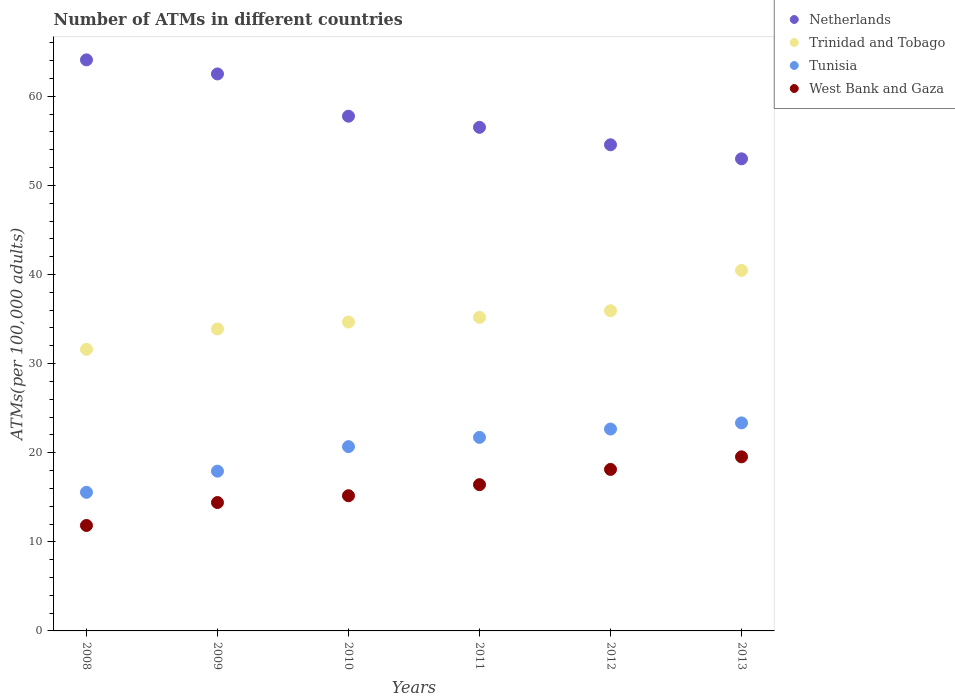How many different coloured dotlines are there?
Your answer should be very brief. 4. Is the number of dotlines equal to the number of legend labels?
Offer a very short reply. Yes. What is the number of ATMs in Tunisia in 2012?
Your response must be concise. 22.66. Across all years, what is the maximum number of ATMs in West Bank and Gaza?
Provide a succinct answer. 19.54. Across all years, what is the minimum number of ATMs in Trinidad and Tobago?
Provide a succinct answer. 31.6. What is the total number of ATMs in West Bank and Gaza in the graph?
Your response must be concise. 95.5. What is the difference between the number of ATMs in Trinidad and Tobago in 2008 and that in 2013?
Give a very brief answer. -8.86. What is the difference between the number of ATMs in West Bank and Gaza in 2010 and the number of ATMs in Netherlands in 2012?
Make the answer very short. -39.39. What is the average number of ATMs in West Bank and Gaza per year?
Your answer should be compact. 15.92. In the year 2008, what is the difference between the number of ATMs in Tunisia and number of ATMs in Netherlands?
Your answer should be compact. -48.54. What is the ratio of the number of ATMs in Netherlands in 2008 to that in 2011?
Your response must be concise. 1.13. Is the number of ATMs in Trinidad and Tobago in 2012 less than that in 2013?
Provide a short and direct response. Yes. What is the difference between the highest and the second highest number of ATMs in Tunisia?
Your answer should be very brief. 0.69. What is the difference between the highest and the lowest number of ATMs in West Bank and Gaza?
Ensure brevity in your answer.  7.7. In how many years, is the number of ATMs in Tunisia greater than the average number of ATMs in Tunisia taken over all years?
Keep it short and to the point. 4. Is it the case that in every year, the sum of the number of ATMs in Netherlands and number of ATMs in West Bank and Gaza  is greater than the sum of number of ATMs in Trinidad and Tobago and number of ATMs in Tunisia?
Provide a short and direct response. No. Is it the case that in every year, the sum of the number of ATMs in Tunisia and number of ATMs in Trinidad and Tobago  is greater than the number of ATMs in West Bank and Gaza?
Provide a short and direct response. Yes. How many dotlines are there?
Provide a short and direct response. 4. How many years are there in the graph?
Provide a short and direct response. 6. What is the difference between two consecutive major ticks on the Y-axis?
Keep it short and to the point. 10. Where does the legend appear in the graph?
Your answer should be very brief. Top right. How many legend labels are there?
Provide a succinct answer. 4. What is the title of the graph?
Give a very brief answer. Number of ATMs in different countries. Does "Guam" appear as one of the legend labels in the graph?
Your answer should be compact. No. What is the label or title of the Y-axis?
Ensure brevity in your answer.  ATMs(per 100,0 adults). What is the ATMs(per 100,000 adults) of Netherlands in 2008?
Provide a succinct answer. 64.1. What is the ATMs(per 100,000 adults) in Trinidad and Tobago in 2008?
Your answer should be compact. 31.6. What is the ATMs(per 100,000 adults) of Tunisia in 2008?
Give a very brief answer. 15.56. What is the ATMs(per 100,000 adults) of West Bank and Gaza in 2008?
Your answer should be very brief. 11.84. What is the ATMs(per 100,000 adults) in Netherlands in 2009?
Your answer should be very brief. 62.52. What is the ATMs(per 100,000 adults) in Trinidad and Tobago in 2009?
Your response must be concise. 33.89. What is the ATMs(per 100,000 adults) of Tunisia in 2009?
Keep it short and to the point. 17.93. What is the ATMs(per 100,000 adults) of West Bank and Gaza in 2009?
Offer a very short reply. 14.41. What is the ATMs(per 100,000 adults) of Netherlands in 2010?
Provide a short and direct response. 57.77. What is the ATMs(per 100,000 adults) of Trinidad and Tobago in 2010?
Your answer should be compact. 34.67. What is the ATMs(per 100,000 adults) of Tunisia in 2010?
Your answer should be very brief. 20.68. What is the ATMs(per 100,000 adults) of West Bank and Gaza in 2010?
Make the answer very short. 15.17. What is the ATMs(per 100,000 adults) of Netherlands in 2011?
Your response must be concise. 56.52. What is the ATMs(per 100,000 adults) of Trinidad and Tobago in 2011?
Offer a very short reply. 35.19. What is the ATMs(per 100,000 adults) in Tunisia in 2011?
Your answer should be very brief. 21.72. What is the ATMs(per 100,000 adults) of West Bank and Gaza in 2011?
Make the answer very short. 16.42. What is the ATMs(per 100,000 adults) in Netherlands in 2012?
Your answer should be very brief. 54.56. What is the ATMs(per 100,000 adults) of Trinidad and Tobago in 2012?
Keep it short and to the point. 35.94. What is the ATMs(per 100,000 adults) of Tunisia in 2012?
Your answer should be compact. 22.66. What is the ATMs(per 100,000 adults) in West Bank and Gaza in 2012?
Your response must be concise. 18.13. What is the ATMs(per 100,000 adults) of Netherlands in 2013?
Offer a very short reply. 52.99. What is the ATMs(per 100,000 adults) in Trinidad and Tobago in 2013?
Provide a succinct answer. 40.47. What is the ATMs(per 100,000 adults) in Tunisia in 2013?
Offer a terse response. 23.35. What is the ATMs(per 100,000 adults) in West Bank and Gaza in 2013?
Your answer should be compact. 19.54. Across all years, what is the maximum ATMs(per 100,000 adults) of Netherlands?
Your response must be concise. 64.1. Across all years, what is the maximum ATMs(per 100,000 adults) in Trinidad and Tobago?
Provide a succinct answer. 40.47. Across all years, what is the maximum ATMs(per 100,000 adults) in Tunisia?
Your response must be concise. 23.35. Across all years, what is the maximum ATMs(per 100,000 adults) in West Bank and Gaza?
Give a very brief answer. 19.54. Across all years, what is the minimum ATMs(per 100,000 adults) in Netherlands?
Offer a very short reply. 52.99. Across all years, what is the minimum ATMs(per 100,000 adults) in Trinidad and Tobago?
Your answer should be very brief. 31.6. Across all years, what is the minimum ATMs(per 100,000 adults) of Tunisia?
Provide a short and direct response. 15.56. Across all years, what is the minimum ATMs(per 100,000 adults) of West Bank and Gaza?
Ensure brevity in your answer.  11.84. What is the total ATMs(per 100,000 adults) of Netherlands in the graph?
Make the answer very short. 348.46. What is the total ATMs(per 100,000 adults) in Trinidad and Tobago in the graph?
Ensure brevity in your answer.  211.76. What is the total ATMs(per 100,000 adults) of Tunisia in the graph?
Offer a terse response. 121.9. What is the total ATMs(per 100,000 adults) of West Bank and Gaza in the graph?
Give a very brief answer. 95.5. What is the difference between the ATMs(per 100,000 adults) in Netherlands in 2008 and that in 2009?
Make the answer very short. 1.58. What is the difference between the ATMs(per 100,000 adults) in Trinidad and Tobago in 2008 and that in 2009?
Offer a terse response. -2.29. What is the difference between the ATMs(per 100,000 adults) in Tunisia in 2008 and that in 2009?
Give a very brief answer. -2.37. What is the difference between the ATMs(per 100,000 adults) in West Bank and Gaza in 2008 and that in 2009?
Keep it short and to the point. -2.57. What is the difference between the ATMs(per 100,000 adults) in Netherlands in 2008 and that in 2010?
Keep it short and to the point. 6.32. What is the difference between the ATMs(per 100,000 adults) of Trinidad and Tobago in 2008 and that in 2010?
Offer a terse response. -3.06. What is the difference between the ATMs(per 100,000 adults) of Tunisia in 2008 and that in 2010?
Your response must be concise. -5.13. What is the difference between the ATMs(per 100,000 adults) of West Bank and Gaza in 2008 and that in 2010?
Keep it short and to the point. -3.34. What is the difference between the ATMs(per 100,000 adults) in Netherlands in 2008 and that in 2011?
Offer a very short reply. 7.57. What is the difference between the ATMs(per 100,000 adults) in Trinidad and Tobago in 2008 and that in 2011?
Make the answer very short. -3.59. What is the difference between the ATMs(per 100,000 adults) of Tunisia in 2008 and that in 2011?
Provide a short and direct response. -6.17. What is the difference between the ATMs(per 100,000 adults) in West Bank and Gaza in 2008 and that in 2011?
Provide a succinct answer. -4.58. What is the difference between the ATMs(per 100,000 adults) of Netherlands in 2008 and that in 2012?
Your answer should be compact. 9.53. What is the difference between the ATMs(per 100,000 adults) of Trinidad and Tobago in 2008 and that in 2012?
Make the answer very short. -4.33. What is the difference between the ATMs(per 100,000 adults) in Tunisia in 2008 and that in 2012?
Your answer should be very brief. -7.1. What is the difference between the ATMs(per 100,000 adults) of West Bank and Gaza in 2008 and that in 2012?
Your answer should be very brief. -6.29. What is the difference between the ATMs(per 100,000 adults) of Netherlands in 2008 and that in 2013?
Ensure brevity in your answer.  11.11. What is the difference between the ATMs(per 100,000 adults) in Trinidad and Tobago in 2008 and that in 2013?
Your answer should be very brief. -8.86. What is the difference between the ATMs(per 100,000 adults) in Tunisia in 2008 and that in 2013?
Give a very brief answer. -7.79. What is the difference between the ATMs(per 100,000 adults) of West Bank and Gaza in 2008 and that in 2013?
Ensure brevity in your answer.  -7.7. What is the difference between the ATMs(per 100,000 adults) of Netherlands in 2009 and that in 2010?
Provide a succinct answer. 4.74. What is the difference between the ATMs(per 100,000 adults) of Trinidad and Tobago in 2009 and that in 2010?
Offer a very short reply. -0.78. What is the difference between the ATMs(per 100,000 adults) in Tunisia in 2009 and that in 2010?
Your response must be concise. -2.75. What is the difference between the ATMs(per 100,000 adults) in West Bank and Gaza in 2009 and that in 2010?
Your response must be concise. -0.76. What is the difference between the ATMs(per 100,000 adults) of Netherlands in 2009 and that in 2011?
Provide a short and direct response. 5.99. What is the difference between the ATMs(per 100,000 adults) in Trinidad and Tobago in 2009 and that in 2011?
Make the answer very short. -1.3. What is the difference between the ATMs(per 100,000 adults) of Tunisia in 2009 and that in 2011?
Make the answer very short. -3.79. What is the difference between the ATMs(per 100,000 adults) of West Bank and Gaza in 2009 and that in 2011?
Provide a succinct answer. -2.01. What is the difference between the ATMs(per 100,000 adults) in Netherlands in 2009 and that in 2012?
Your answer should be compact. 7.95. What is the difference between the ATMs(per 100,000 adults) of Trinidad and Tobago in 2009 and that in 2012?
Ensure brevity in your answer.  -2.05. What is the difference between the ATMs(per 100,000 adults) of Tunisia in 2009 and that in 2012?
Provide a succinct answer. -4.73. What is the difference between the ATMs(per 100,000 adults) in West Bank and Gaza in 2009 and that in 2012?
Offer a very short reply. -3.72. What is the difference between the ATMs(per 100,000 adults) in Netherlands in 2009 and that in 2013?
Give a very brief answer. 9.53. What is the difference between the ATMs(per 100,000 adults) in Trinidad and Tobago in 2009 and that in 2013?
Your answer should be compact. -6.58. What is the difference between the ATMs(per 100,000 adults) of Tunisia in 2009 and that in 2013?
Your answer should be very brief. -5.42. What is the difference between the ATMs(per 100,000 adults) in West Bank and Gaza in 2009 and that in 2013?
Provide a succinct answer. -5.13. What is the difference between the ATMs(per 100,000 adults) in Netherlands in 2010 and that in 2011?
Provide a succinct answer. 1.25. What is the difference between the ATMs(per 100,000 adults) of Trinidad and Tobago in 2010 and that in 2011?
Give a very brief answer. -0.52. What is the difference between the ATMs(per 100,000 adults) in Tunisia in 2010 and that in 2011?
Ensure brevity in your answer.  -1.04. What is the difference between the ATMs(per 100,000 adults) of West Bank and Gaza in 2010 and that in 2011?
Ensure brevity in your answer.  -1.24. What is the difference between the ATMs(per 100,000 adults) of Netherlands in 2010 and that in 2012?
Your answer should be compact. 3.21. What is the difference between the ATMs(per 100,000 adults) in Trinidad and Tobago in 2010 and that in 2012?
Make the answer very short. -1.27. What is the difference between the ATMs(per 100,000 adults) in Tunisia in 2010 and that in 2012?
Offer a terse response. -1.98. What is the difference between the ATMs(per 100,000 adults) in West Bank and Gaza in 2010 and that in 2012?
Ensure brevity in your answer.  -2.95. What is the difference between the ATMs(per 100,000 adults) in Netherlands in 2010 and that in 2013?
Provide a succinct answer. 4.78. What is the difference between the ATMs(per 100,000 adults) in Trinidad and Tobago in 2010 and that in 2013?
Offer a very short reply. -5.8. What is the difference between the ATMs(per 100,000 adults) of Tunisia in 2010 and that in 2013?
Your answer should be very brief. -2.67. What is the difference between the ATMs(per 100,000 adults) of West Bank and Gaza in 2010 and that in 2013?
Your response must be concise. -4.37. What is the difference between the ATMs(per 100,000 adults) in Netherlands in 2011 and that in 2012?
Keep it short and to the point. 1.96. What is the difference between the ATMs(per 100,000 adults) of Trinidad and Tobago in 2011 and that in 2012?
Give a very brief answer. -0.75. What is the difference between the ATMs(per 100,000 adults) in Tunisia in 2011 and that in 2012?
Your response must be concise. -0.94. What is the difference between the ATMs(per 100,000 adults) in West Bank and Gaza in 2011 and that in 2012?
Provide a succinct answer. -1.71. What is the difference between the ATMs(per 100,000 adults) of Netherlands in 2011 and that in 2013?
Ensure brevity in your answer.  3.53. What is the difference between the ATMs(per 100,000 adults) in Trinidad and Tobago in 2011 and that in 2013?
Your answer should be very brief. -5.28. What is the difference between the ATMs(per 100,000 adults) of Tunisia in 2011 and that in 2013?
Give a very brief answer. -1.63. What is the difference between the ATMs(per 100,000 adults) in West Bank and Gaza in 2011 and that in 2013?
Your response must be concise. -3.12. What is the difference between the ATMs(per 100,000 adults) in Netherlands in 2012 and that in 2013?
Your response must be concise. 1.58. What is the difference between the ATMs(per 100,000 adults) in Trinidad and Tobago in 2012 and that in 2013?
Your answer should be compact. -4.53. What is the difference between the ATMs(per 100,000 adults) in Tunisia in 2012 and that in 2013?
Your answer should be very brief. -0.69. What is the difference between the ATMs(per 100,000 adults) of West Bank and Gaza in 2012 and that in 2013?
Offer a very short reply. -1.41. What is the difference between the ATMs(per 100,000 adults) in Netherlands in 2008 and the ATMs(per 100,000 adults) in Trinidad and Tobago in 2009?
Ensure brevity in your answer.  30.21. What is the difference between the ATMs(per 100,000 adults) in Netherlands in 2008 and the ATMs(per 100,000 adults) in Tunisia in 2009?
Offer a terse response. 46.17. What is the difference between the ATMs(per 100,000 adults) of Netherlands in 2008 and the ATMs(per 100,000 adults) of West Bank and Gaza in 2009?
Your answer should be very brief. 49.69. What is the difference between the ATMs(per 100,000 adults) in Trinidad and Tobago in 2008 and the ATMs(per 100,000 adults) in Tunisia in 2009?
Give a very brief answer. 13.67. What is the difference between the ATMs(per 100,000 adults) in Trinidad and Tobago in 2008 and the ATMs(per 100,000 adults) in West Bank and Gaza in 2009?
Provide a short and direct response. 17.19. What is the difference between the ATMs(per 100,000 adults) in Tunisia in 2008 and the ATMs(per 100,000 adults) in West Bank and Gaza in 2009?
Give a very brief answer. 1.15. What is the difference between the ATMs(per 100,000 adults) of Netherlands in 2008 and the ATMs(per 100,000 adults) of Trinidad and Tobago in 2010?
Offer a terse response. 29.43. What is the difference between the ATMs(per 100,000 adults) in Netherlands in 2008 and the ATMs(per 100,000 adults) in Tunisia in 2010?
Give a very brief answer. 43.41. What is the difference between the ATMs(per 100,000 adults) in Netherlands in 2008 and the ATMs(per 100,000 adults) in West Bank and Gaza in 2010?
Your answer should be compact. 48.92. What is the difference between the ATMs(per 100,000 adults) of Trinidad and Tobago in 2008 and the ATMs(per 100,000 adults) of Tunisia in 2010?
Your answer should be very brief. 10.92. What is the difference between the ATMs(per 100,000 adults) in Trinidad and Tobago in 2008 and the ATMs(per 100,000 adults) in West Bank and Gaza in 2010?
Offer a terse response. 16.43. What is the difference between the ATMs(per 100,000 adults) of Tunisia in 2008 and the ATMs(per 100,000 adults) of West Bank and Gaza in 2010?
Provide a short and direct response. 0.38. What is the difference between the ATMs(per 100,000 adults) in Netherlands in 2008 and the ATMs(per 100,000 adults) in Trinidad and Tobago in 2011?
Provide a succinct answer. 28.9. What is the difference between the ATMs(per 100,000 adults) in Netherlands in 2008 and the ATMs(per 100,000 adults) in Tunisia in 2011?
Offer a very short reply. 42.37. What is the difference between the ATMs(per 100,000 adults) in Netherlands in 2008 and the ATMs(per 100,000 adults) in West Bank and Gaza in 2011?
Make the answer very short. 47.68. What is the difference between the ATMs(per 100,000 adults) in Trinidad and Tobago in 2008 and the ATMs(per 100,000 adults) in Tunisia in 2011?
Ensure brevity in your answer.  9.88. What is the difference between the ATMs(per 100,000 adults) of Trinidad and Tobago in 2008 and the ATMs(per 100,000 adults) of West Bank and Gaza in 2011?
Your answer should be very brief. 15.19. What is the difference between the ATMs(per 100,000 adults) of Tunisia in 2008 and the ATMs(per 100,000 adults) of West Bank and Gaza in 2011?
Your answer should be very brief. -0.86. What is the difference between the ATMs(per 100,000 adults) in Netherlands in 2008 and the ATMs(per 100,000 adults) in Trinidad and Tobago in 2012?
Make the answer very short. 28.16. What is the difference between the ATMs(per 100,000 adults) of Netherlands in 2008 and the ATMs(per 100,000 adults) of Tunisia in 2012?
Keep it short and to the point. 41.44. What is the difference between the ATMs(per 100,000 adults) of Netherlands in 2008 and the ATMs(per 100,000 adults) of West Bank and Gaza in 2012?
Give a very brief answer. 45.97. What is the difference between the ATMs(per 100,000 adults) in Trinidad and Tobago in 2008 and the ATMs(per 100,000 adults) in Tunisia in 2012?
Offer a very short reply. 8.94. What is the difference between the ATMs(per 100,000 adults) of Trinidad and Tobago in 2008 and the ATMs(per 100,000 adults) of West Bank and Gaza in 2012?
Your response must be concise. 13.48. What is the difference between the ATMs(per 100,000 adults) in Tunisia in 2008 and the ATMs(per 100,000 adults) in West Bank and Gaza in 2012?
Your answer should be very brief. -2.57. What is the difference between the ATMs(per 100,000 adults) of Netherlands in 2008 and the ATMs(per 100,000 adults) of Trinidad and Tobago in 2013?
Your response must be concise. 23.63. What is the difference between the ATMs(per 100,000 adults) of Netherlands in 2008 and the ATMs(per 100,000 adults) of Tunisia in 2013?
Your answer should be compact. 40.75. What is the difference between the ATMs(per 100,000 adults) in Netherlands in 2008 and the ATMs(per 100,000 adults) in West Bank and Gaza in 2013?
Give a very brief answer. 44.56. What is the difference between the ATMs(per 100,000 adults) in Trinidad and Tobago in 2008 and the ATMs(per 100,000 adults) in Tunisia in 2013?
Your response must be concise. 8.25. What is the difference between the ATMs(per 100,000 adults) of Trinidad and Tobago in 2008 and the ATMs(per 100,000 adults) of West Bank and Gaza in 2013?
Ensure brevity in your answer.  12.06. What is the difference between the ATMs(per 100,000 adults) in Tunisia in 2008 and the ATMs(per 100,000 adults) in West Bank and Gaza in 2013?
Ensure brevity in your answer.  -3.98. What is the difference between the ATMs(per 100,000 adults) of Netherlands in 2009 and the ATMs(per 100,000 adults) of Trinidad and Tobago in 2010?
Provide a short and direct response. 27.85. What is the difference between the ATMs(per 100,000 adults) of Netherlands in 2009 and the ATMs(per 100,000 adults) of Tunisia in 2010?
Offer a terse response. 41.83. What is the difference between the ATMs(per 100,000 adults) of Netherlands in 2009 and the ATMs(per 100,000 adults) of West Bank and Gaza in 2010?
Give a very brief answer. 47.34. What is the difference between the ATMs(per 100,000 adults) in Trinidad and Tobago in 2009 and the ATMs(per 100,000 adults) in Tunisia in 2010?
Offer a terse response. 13.21. What is the difference between the ATMs(per 100,000 adults) of Trinidad and Tobago in 2009 and the ATMs(per 100,000 adults) of West Bank and Gaza in 2010?
Offer a terse response. 18.72. What is the difference between the ATMs(per 100,000 adults) of Tunisia in 2009 and the ATMs(per 100,000 adults) of West Bank and Gaza in 2010?
Your answer should be very brief. 2.76. What is the difference between the ATMs(per 100,000 adults) of Netherlands in 2009 and the ATMs(per 100,000 adults) of Trinidad and Tobago in 2011?
Provide a succinct answer. 27.33. What is the difference between the ATMs(per 100,000 adults) of Netherlands in 2009 and the ATMs(per 100,000 adults) of Tunisia in 2011?
Offer a very short reply. 40.79. What is the difference between the ATMs(per 100,000 adults) of Netherlands in 2009 and the ATMs(per 100,000 adults) of West Bank and Gaza in 2011?
Offer a terse response. 46.1. What is the difference between the ATMs(per 100,000 adults) of Trinidad and Tobago in 2009 and the ATMs(per 100,000 adults) of Tunisia in 2011?
Give a very brief answer. 12.17. What is the difference between the ATMs(per 100,000 adults) of Trinidad and Tobago in 2009 and the ATMs(per 100,000 adults) of West Bank and Gaza in 2011?
Your response must be concise. 17.47. What is the difference between the ATMs(per 100,000 adults) in Tunisia in 2009 and the ATMs(per 100,000 adults) in West Bank and Gaza in 2011?
Make the answer very short. 1.51. What is the difference between the ATMs(per 100,000 adults) in Netherlands in 2009 and the ATMs(per 100,000 adults) in Trinidad and Tobago in 2012?
Your answer should be very brief. 26.58. What is the difference between the ATMs(per 100,000 adults) in Netherlands in 2009 and the ATMs(per 100,000 adults) in Tunisia in 2012?
Keep it short and to the point. 39.86. What is the difference between the ATMs(per 100,000 adults) in Netherlands in 2009 and the ATMs(per 100,000 adults) in West Bank and Gaza in 2012?
Offer a very short reply. 44.39. What is the difference between the ATMs(per 100,000 adults) of Trinidad and Tobago in 2009 and the ATMs(per 100,000 adults) of Tunisia in 2012?
Provide a short and direct response. 11.23. What is the difference between the ATMs(per 100,000 adults) of Trinidad and Tobago in 2009 and the ATMs(per 100,000 adults) of West Bank and Gaza in 2012?
Ensure brevity in your answer.  15.76. What is the difference between the ATMs(per 100,000 adults) in Tunisia in 2009 and the ATMs(per 100,000 adults) in West Bank and Gaza in 2012?
Your answer should be very brief. -0.2. What is the difference between the ATMs(per 100,000 adults) in Netherlands in 2009 and the ATMs(per 100,000 adults) in Trinidad and Tobago in 2013?
Give a very brief answer. 22.05. What is the difference between the ATMs(per 100,000 adults) in Netherlands in 2009 and the ATMs(per 100,000 adults) in Tunisia in 2013?
Give a very brief answer. 39.17. What is the difference between the ATMs(per 100,000 adults) of Netherlands in 2009 and the ATMs(per 100,000 adults) of West Bank and Gaza in 2013?
Ensure brevity in your answer.  42.98. What is the difference between the ATMs(per 100,000 adults) in Trinidad and Tobago in 2009 and the ATMs(per 100,000 adults) in Tunisia in 2013?
Keep it short and to the point. 10.54. What is the difference between the ATMs(per 100,000 adults) in Trinidad and Tobago in 2009 and the ATMs(per 100,000 adults) in West Bank and Gaza in 2013?
Provide a short and direct response. 14.35. What is the difference between the ATMs(per 100,000 adults) in Tunisia in 2009 and the ATMs(per 100,000 adults) in West Bank and Gaza in 2013?
Keep it short and to the point. -1.61. What is the difference between the ATMs(per 100,000 adults) of Netherlands in 2010 and the ATMs(per 100,000 adults) of Trinidad and Tobago in 2011?
Offer a terse response. 22.58. What is the difference between the ATMs(per 100,000 adults) in Netherlands in 2010 and the ATMs(per 100,000 adults) in Tunisia in 2011?
Provide a short and direct response. 36.05. What is the difference between the ATMs(per 100,000 adults) in Netherlands in 2010 and the ATMs(per 100,000 adults) in West Bank and Gaza in 2011?
Give a very brief answer. 41.36. What is the difference between the ATMs(per 100,000 adults) of Trinidad and Tobago in 2010 and the ATMs(per 100,000 adults) of Tunisia in 2011?
Your answer should be very brief. 12.94. What is the difference between the ATMs(per 100,000 adults) of Trinidad and Tobago in 2010 and the ATMs(per 100,000 adults) of West Bank and Gaza in 2011?
Give a very brief answer. 18.25. What is the difference between the ATMs(per 100,000 adults) in Tunisia in 2010 and the ATMs(per 100,000 adults) in West Bank and Gaza in 2011?
Your answer should be compact. 4.27. What is the difference between the ATMs(per 100,000 adults) in Netherlands in 2010 and the ATMs(per 100,000 adults) in Trinidad and Tobago in 2012?
Keep it short and to the point. 21.84. What is the difference between the ATMs(per 100,000 adults) in Netherlands in 2010 and the ATMs(per 100,000 adults) in Tunisia in 2012?
Your answer should be very brief. 35.11. What is the difference between the ATMs(per 100,000 adults) in Netherlands in 2010 and the ATMs(per 100,000 adults) in West Bank and Gaza in 2012?
Ensure brevity in your answer.  39.64. What is the difference between the ATMs(per 100,000 adults) of Trinidad and Tobago in 2010 and the ATMs(per 100,000 adults) of Tunisia in 2012?
Make the answer very short. 12.01. What is the difference between the ATMs(per 100,000 adults) in Trinidad and Tobago in 2010 and the ATMs(per 100,000 adults) in West Bank and Gaza in 2012?
Make the answer very short. 16.54. What is the difference between the ATMs(per 100,000 adults) in Tunisia in 2010 and the ATMs(per 100,000 adults) in West Bank and Gaza in 2012?
Keep it short and to the point. 2.56. What is the difference between the ATMs(per 100,000 adults) in Netherlands in 2010 and the ATMs(per 100,000 adults) in Trinidad and Tobago in 2013?
Your answer should be compact. 17.31. What is the difference between the ATMs(per 100,000 adults) in Netherlands in 2010 and the ATMs(per 100,000 adults) in Tunisia in 2013?
Make the answer very short. 34.42. What is the difference between the ATMs(per 100,000 adults) in Netherlands in 2010 and the ATMs(per 100,000 adults) in West Bank and Gaza in 2013?
Ensure brevity in your answer.  38.23. What is the difference between the ATMs(per 100,000 adults) in Trinidad and Tobago in 2010 and the ATMs(per 100,000 adults) in Tunisia in 2013?
Your response must be concise. 11.32. What is the difference between the ATMs(per 100,000 adults) in Trinidad and Tobago in 2010 and the ATMs(per 100,000 adults) in West Bank and Gaza in 2013?
Your answer should be compact. 15.13. What is the difference between the ATMs(per 100,000 adults) of Tunisia in 2010 and the ATMs(per 100,000 adults) of West Bank and Gaza in 2013?
Your answer should be very brief. 1.14. What is the difference between the ATMs(per 100,000 adults) of Netherlands in 2011 and the ATMs(per 100,000 adults) of Trinidad and Tobago in 2012?
Your answer should be very brief. 20.59. What is the difference between the ATMs(per 100,000 adults) of Netherlands in 2011 and the ATMs(per 100,000 adults) of Tunisia in 2012?
Provide a succinct answer. 33.86. What is the difference between the ATMs(per 100,000 adults) of Netherlands in 2011 and the ATMs(per 100,000 adults) of West Bank and Gaza in 2012?
Ensure brevity in your answer.  38.4. What is the difference between the ATMs(per 100,000 adults) in Trinidad and Tobago in 2011 and the ATMs(per 100,000 adults) in Tunisia in 2012?
Keep it short and to the point. 12.53. What is the difference between the ATMs(per 100,000 adults) in Trinidad and Tobago in 2011 and the ATMs(per 100,000 adults) in West Bank and Gaza in 2012?
Give a very brief answer. 17.06. What is the difference between the ATMs(per 100,000 adults) in Tunisia in 2011 and the ATMs(per 100,000 adults) in West Bank and Gaza in 2012?
Ensure brevity in your answer.  3.59. What is the difference between the ATMs(per 100,000 adults) in Netherlands in 2011 and the ATMs(per 100,000 adults) in Trinidad and Tobago in 2013?
Give a very brief answer. 16.06. What is the difference between the ATMs(per 100,000 adults) of Netherlands in 2011 and the ATMs(per 100,000 adults) of Tunisia in 2013?
Your response must be concise. 33.17. What is the difference between the ATMs(per 100,000 adults) in Netherlands in 2011 and the ATMs(per 100,000 adults) in West Bank and Gaza in 2013?
Your answer should be compact. 36.98. What is the difference between the ATMs(per 100,000 adults) of Trinidad and Tobago in 2011 and the ATMs(per 100,000 adults) of Tunisia in 2013?
Offer a very short reply. 11.84. What is the difference between the ATMs(per 100,000 adults) of Trinidad and Tobago in 2011 and the ATMs(per 100,000 adults) of West Bank and Gaza in 2013?
Keep it short and to the point. 15.65. What is the difference between the ATMs(per 100,000 adults) in Tunisia in 2011 and the ATMs(per 100,000 adults) in West Bank and Gaza in 2013?
Your answer should be very brief. 2.18. What is the difference between the ATMs(per 100,000 adults) in Netherlands in 2012 and the ATMs(per 100,000 adults) in Trinidad and Tobago in 2013?
Your response must be concise. 14.1. What is the difference between the ATMs(per 100,000 adults) of Netherlands in 2012 and the ATMs(per 100,000 adults) of Tunisia in 2013?
Provide a short and direct response. 31.22. What is the difference between the ATMs(per 100,000 adults) in Netherlands in 2012 and the ATMs(per 100,000 adults) in West Bank and Gaza in 2013?
Your answer should be compact. 35.02. What is the difference between the ATMs(per 100,000 adults) of Trinidad and Tobago in 2012 and the ATMs(per 100,000 adults) of Tunisia in 2013?
Offer a terse response. 12.59. What is the difference between the ATMs(per 100,000 adults) of Trinidad and Tobago in 2012 and the ATMs(per 100,000 adults) of West Bank and Gaza in 2013?
Provide a succinct answer. 16.4. What is the difference between the ATMs(per 100,000 adults) in Tunisia in 2012 and the ATMs(per 100,000 adults) in West Bank and Gaza in 2013?
Your answer should be compact. 3.12. What is the average ATMs(per 100,000 adults) of Netherlands per year?
Your answer should be very brief. 58.08. What is the average ATMs(per 100,000 adults) of Trinidad and Tobago per year?
Give a very brief answer. 35.29. What is the average ATMs(per 100,000 adults) in Tunisia per year?
Offer a very short reply. 20.32. What is the average ATMs(per 100,000 adults) in West Bank and Gaza per year?
Give a very brief answer. 15.92. In the year 2008, what is the difference between the ATMs(per 100,000 adults) in Netherlands and ATMs(per 100,000 adults) in Trinidad and Tobago?
Provide a succinct answer. 32.49. In the year 2008, what is the difference between the ATMs(per 100,000 adults) in Netherlands and ATMs(per 100,000 adults) in Tunisia?
Provide a short and direct response. 48.54. In the year 2008, what is the difference between the ATMs(per 100,000 adults) in Netherlands and ATMs(per 100,000 adults) in West Bank and Gaza?
Your response must be concise. 52.26. In the year 2008, what is the difference between the ATMs(per 100,000 adults) in Trinidad and Tobago and ATMs(per 100,000 adults) in Tunisia?
Your answer should be very brief. 16.05. In the year 2008, what is the difference between the ATMs(per 100,000 adults) of Trinidad and Tobago and ATMs(per 100,000 adults) of West Bank and Gaza?
Your answer should be very brief. 19.77. In the year 2008, what is the difference between the ATMs(per 100,000 adults) in Tunisia and ATMs(per 100,000 adults) in West Bank and Gaza?
Provide a succinct answer. 3.72. In the year 2009, what is the difference between the ATMs(per 100,000 adults) of Netherlands and ATMs(per 100,000 adults) of Trinidad and Tobago?
Give a very brief answer. 28.63. In the year 2009, what is the difference between the ATMs(per 100,000 adults) in Netherlands and ATMs(per 100,000 adults) in Tunisia?
Keep it short and to the point. 44.59. In the year 2009, what is the difference between the ATMs(per 100,000 adults) of Netherlands and ATMs(per 100,000 adults) of West Bank and Gaza?
Keep it short and to the point. 48.11. In the year 2009, what is the difference between the ATMs(per 100,000 adults) of Trinidad and Tobago and ATMs(per 100,000 adults) of Tunisia?
Give a very brief answer. 15.96. In the year 2009, what is the difference between the ATMs(per 100,000 adults) in Trinidad and Tobago and ATMs(per 100,000 adults) in West Bank and Gaza?
Keep it short and to the point. 19.48. In the year 2009, what is the difference between the ATMs(per 100,000 adults) in Tunisia and ATMs(per 100,000 adults) in West Bank and Gaza?
Provide a short and direct response. 3.52. In the year 2010, what is the difference between the ATMs(per 100,000 adults) of Netherlands and ATMs(per 100,000 adults) of Trinidad and Tobago?
Your response must be concise. 23.1. In the year 2010, what is the difference between the ATMs(per 100,000 adults) of Netherlands and ATMs(per 100,000 adults) of Tunisia?
Ensure brevity in your answer.  37.09. In the year 2010, what is the difference between the ATMs(per 100,000 adults) in Netherlands and ATMs(per 100,000 adults) in West Bank and Gaza?
Offer a terse response. 42.6. In the year 2010, what is the difference between the ATMs(per 100,000 adults) of Trinidad and Tobago and ATMs(per 100,000 adults) of Tunisia?
Offer a very short reply. 13.98. In the year 2010, what is the difference between the ATMs(per 100,000 adults) of Trinidad and Tobago and ATMs(per 100,000 adults) of West Bank and Gaza?
Keep it short and to the point. 19.49. In the year 2010, what is the difference between the ATMs(per 100,000 adults) of Tunisia and ATMs(per 100,000 adults) of West Bank and Gaza?
Make the answer very short. 5.51. In the year 2011, what is the difference between the ATMs(per 100,000 adults) of Netherlands and ATMs(per 100,000 adults) of Trinidad and Tobago?
Provide a succinct answer. 21.33. In the year 2011, what is the difference between the ATMs(per 100,000 adults) in Netherlands and ATMs(per 100,000 adults) in Tunisia?
Your response must be concise. 34.8. In the year 2011, what is the difference between the ATMs(per 100,000 adults) of Netherlands and ATMs(per 100,000 adults) of West Bank and Gaza?
Your response must be concise. 40.11. In the year 2011, what is the difference between the ATMs(per 100,000 adults) of Trinidad and Tobago and ATMs(per 100,000 adults) of Tunisia?
Keep it short and to the point. 13.47. In the year 2011, what is the difference between the ATMs(per 100,000 adults) in Trinidad and Tobago and ATMs(per 100,000 adults) in West Bank and Gaza?
Make the answer very short. 18.78. In the year 2011, what is the difference between the ATMs(per 100,000 adults) in Tunisia and ATMs(per 100,000 adults) in West Bank and Gaza?
Give a very brief answer. 5.31. In the year 2012, what is the difference between the ATMs(per 100,000 adults) of Netherlands and ATMs(per 100,000 adults) of Trinidad and Tobago?
Make the answer very short. 18.63. In the year 2012, what is the difference between the ATMs(per 100,000 adults) in Netherlands and ATMs(per 100,000 adults) in Tunisia?
Make the answer very short. 31.9. In the year 2012, what is the difference between the ATMs(per 100,000 adults) in Netherlands and ATMs(per 100,000 adults) in West Bank and Gaza?
Provide a short and direct response. 36.44. In the year 2012, what is the difference between the ATMs(per 100,000 adults) of Trinidad and Tobago and ATMs(per 100,000 adults) of Tunisia?
Your response must be concise. 13.28. In the year 2012, what is the difference between the ATMs(per 100,000 adults) in Trinidad and Tobago and ATMs(per 100,000 adults) in West Bank and Gaza?
Ensure brevity in your answer.  17.81. In the year 2012, what is the difference between the ATMs(per 100,000 adults) of Tunisia and ATMs(per 100,000 adults) of West Bank and Gaza?
Your response must be concise. 4.53. In the year 2013, what is the difference between the ATMs(per 100,000 adults) in Netherlands and ATMs(per 100,000 adults) in Trinidad and Tobago?
Offer a terse response. 12.52. In the year 2013, what is the difference between the ATMs(per 100,000 adults) in Netherlands and ATMs(per 100,000 adults) in Tunisia?
Keep it short and to the point. 29.64. In the year 2013, what is the difference between the ATMs(per 100,000 adults) of Netherlands and ATMs(per 100,000 adults) of West Bank and Gaza?
Offer a very short reply. 33.45. In the year 2013, what is the difference between the ATMs(per 100,000 adults) of Trinidad and Tobago and ATMs(per 100,000 adults) of Tunisia?
Ensure brevity in your answer.  17.12. In the year 2013, what is the difference between the ATMs(per 100,000 adults) in Trinidad and Tobago and ATMs(per 100,000 adults) in West Bank and Gaza?
Provide a succinct answer. 20.93. In the year 2013, what is the difference between the ATMs(per 100,000 adults) of Tunisia and ATMs(per 100,000 adults) of West Bank and Gaza?
Ensure brevity in your answer.  3.81. What is the ratio of the ATMs(per 100,000 adults) in Netherlands in 2008 to that in 2009?
Provide a succinct answer. 1.03. What is the ratio of the ATMs(per 100,000 adults) of Trinidad and Tobago in 2008 to that in 2009?
Give a very brief answer. 0.93. What is the ratio of the ATMs(per 100,000 adults) of Tunisia in 2008 to that in 2009?
Your response must be concise. 0.87. What is the ratio of the ATMs(per 100,000 adults) of West Bank and Gaza in 2008 to that in 2009?
Make the answer very short. 0.82. What is the ratio of the ATMs(per 100,000 adults) in Netherlands in 2008 to that in 2010?
Your answer should be very brief. 1.11. What is the ratio of the ATMs(per 100,000 adults) in Trinidad and Tobago in 2008 to that in 2010?
Your response must be concise. 0.91. What is the ratio of the ATMs(per 100,000 adults) in Tunisia in 2008 to that in 2010?
Your response must be concise. 0.75. What is the ratio of the ATMs(per 100,000 adults) of West Bank and Gaza in 2008 to that in 2010?
Offer a terse response. 0.78. What is the ratio of the ATMs(per 100,000 adults) in Netherlands in 2008 to that in 2011?
Provide a short and direct response. 1.13. What is the ratio of the ATMs(per 100,000 adults) in Trinidad and Tobago in 2008 to that in 2011?
Your answer should be compact. 0.9. What is the ratio of the ATMs(per 100,000 adults) in Tunisia in 2008 to that in 2011?
Keep it short and to the point. 0.72. What is the ratio of the ATMs(per 100,000 adults) of West Bank and Gaza in 2008 to that in 2011?
Provide a succinct answer. 0.72. What is the ratio of the ATMs(per 100,000 adults) of Netherlands in 2008 to that in 2012?
Provide a succinct answer. 1.17. What is the ratio of the ATMs(per 100,000 adults) of Trinidad and Tobago in 2008 to that in 2012?
Keep it short and to the point. 0.88. What is the ratio of the ATMs(per 100,000 adults) in Tunisia in 2008 to that in 2012?
Your answer should be very brief. 0.69. What is the ratio of the ATMs(per 100,000 adults) of West Bank and Gaza in 2008 to that in 2012?
Your answer should be very brief. 0.65. What is the ratio of the ATMs(per 100,000 adults) of Netherlands in 2008 to that in 2013?
Offer a terse response. 1.21. What is the ratio of the ATMs(per 100,000 adults) in Trinidad and Tobago in 2008 to that in 2013?
Provide a succinct answer. 0.78. What is the ratio of the ATMs(per 100,000 adults) of Tunisia in 2008 to that in 2013?
Your response must be concise. 0.67. What is the ratio of the ATMs(per 100,000 adults) in West Bank and Gaza in 2008 to that in 2013?
Offer a terse response. 0.61. What is the ratio of the ATMs(per 100,000 adults) of Netherlands in 2009 to that in 2010?
Provide a succinct answer. 1.08. What is the ratio of the ATMs(per 100,000 adults) of Trinidad and Tobago in 2009 to that in 2010?
Ensure brevity in your answer.  0.98. What is the ratio of the ATMs(per 100,000 adults) of Tunisia in 2009 to that in 2010?
Provide a short and direct response. 0.87. What is the ratio of the ATMs(per 100,000 adults) of West Bank and Gaza in 2009 to that in 2010?
Ensure brevity in your answer.  0.95. What is the ratio of the ATMs(per 100,000 adults) in Netherlands in 2009 to that in 2011?
Provide a short and direct response. 1.11. What is the ratio of the ATMs(per 100,000 adults) of Tunisia in 2009 to that in 2011?
Offer a terse response. 0.83. What is the ratio of the ATMs(per 100,000 adults) in West Bank and Gaza in 2009 to that in 2011?
Ensure brevity in your answer.  0.88. What is the ratio of the ATMs(per 100,000 adults) in Netherlands in 2009 to that in 2012?
Keep it short and to the point. 1.15. What is the ratio of the ATMs(per 100,000 adults) in Trinidad and Tobago in 2009 to that in 2012?
Ensure brevity in your answer.  0.94. What is the ratio of the ATMs(per 100,000 adults) of Tunisia in 2009 to that in 2012?
Provide a succinct answer. 0.79. What is the ratio of the ATMs(per 100,000 adults) of West Bank and Gaza in 2009 to that in 2012?
Give a very brief answer. 0.79. What is the ratio of the ATMs(per 100,000 adults) of Netherlands in 2009 to that in 2013?
Your answer should be compact. 1.18. What is the ratio of the ATMs(per 100,000 adults) of Trinidad and Tobago in 2009 to that in 2013?
Your answer should be very brief. 0.84. What is the ratio of the ATMs(per 100,000 adults) of Tunisia in 2009 to that in 2013?
Offer a terse response. 0.77. What is the ratio of the ATMs(per 100,000 adults) of West Bank and Gaza in 2009 to that in 2013?
Your answer should be compact. 0.74. What is the ratio of the ATMs(per 100,000 adults) of Netherlands in 2010 to that in 2011?
Provide a succinct answer. 1.02. What is the ratio of the ATMs(per 100,000 adults) of Trinidad and Tobago in 2010 to that in 2011?
Offer a terse response. 0.99. What is the ratio of the ATMs(per 100,000 adults) of Tunisia in 2010 to that in 2011?
Give a very brief answer. 0.95. What is the ratio of the ATMs(per 100,000 adults) of West Bank and Gaza in 2010 to that in 2011?
Provide a succinct answer. 0.92. What is the ratio of the ATMs(per 100,000 adults) in Netherlands in 2010 to that in 2012?
Provide a succinct answer. 1.06. What is the ratio of the ATMs(per 100,000 adults) of Trinidad and Tobago in 2010 to that in 2012?
Ensure brevity in your answer.  0.96. What is the ratio of the ATMs(per 100,000 adults) in Tunisia in 2010 to that in 2012?
Offer a very short reply. 0.91. What is the ratio of the ATMs(per 100,000 adults) of West Bank and Gaza in 2010 to that in 2012?
Keep it short and to the point. 0.84. What is the ratio of the ATMs(per 100,000 adults) in Netherlands in 2010 to that in 2013?
Provide a succinct answer. 1.09. What is the ratio of the ATMs(per 100,000 adults) in Trinidad and Tobago in 2010 to that in 2013?
Ensure brevity in your answer.  0.86. What is the ratio of the ATMs(per 100,000 adults) in Tunisia in 2010 to that in 2013?
Provide a succinct answer. 0.89. What is the ratio of the ATMs(per 100,000 adults) of West Bank and Gaza in 2010 to that in 2013?
Give a very brief answer. 0.78. What is the ratio of the ATMs(per 100,000 adults) in Netherlands in 2011 to that in 2012?
Offer a very short reply. 1.04. What is the ratio of the ATMs(per 100,000 adults) of Trinidad and Tobago in 2011 to that in 2012?
Provide a short and direct response. 0.98. What is the ratio of the ATMs(per 100,000 adults) in Tunisia in 2011 to that in 2012?
Offer a terse response. 0.96. What is the ratio of the ATMs(per 100,000 adults) in West Bank and Gaza in 2011 to that in 2012?
Make the answer very short. 0.91. What is the ratio of the ATMs(per 100,000 adults) of Netherlands in 2011 to that in 2013?
Give a very brief answer. 1.07. What is the ratio of the ATMs(per 100,000 adults) of Trinidad and Tobago in 2011 to that in 2013?
Offer a very short reply. 0.87. What is the ratio of the ATMs(per 100,000 adults) in Tunisia in 2011 to that in 2013?
Ensure brevity in your answer.  0.93. What is the ratio of the ATMs(per 100,000 adults) in West Bank and Gaza in 2011 to that in 2013?
Give a very brief answer. 0.84. What is the ratio of the ATMs(per 100,000 adults) of Netherlands in 2012 to that in 2013?
Your response must be concise. 1.03. What is the ratio of the ATMs(per 100,000 adults) of Trinidad and Tobago in 2012 to that in 2013?
Ensure brevity in your answer.  0.89. What is the ratio of the ATMs(per 100,000 adults) in Tunisia in 2012 to that in 2013?
Ensure brevity in your answer.  0.97. What is the ratio of the ATMs(per 100,000 adults) of West Bank and Gaza in 2012 to that in 2013?
Provide a succinct answer. 0.93. What is the difference between the highest and the second highest ATMs(per 100,000 adults) of Netherlands?
Your answer should be very brief. 1.58. What is the difference between the highest and the second highest ATMs(per 100,000 adults) of Trinidad and Tobago?
Your answer should be compact. 4.53. What is the difference between the highest and the second highest ATMs(per 100,000 adults) in Tunisia?
Ensure brevity in your answer.  0.69. What is the difference between the highest and the second highest ATMs(per 100,000 adults) of West Bank and Gaza?
Ensure brevity in your answer.  1.41. What is the difference between the highest and the lowest ATMs(per 100,000 adults) in Netherlands?
Your answer should be very brief. 11.11. What is the difference between the highest and the lowest ATMs(per 100,000 adults) of Trinidad and Tobago?
Your answer should be very brief. 8.86. What is the difference between the highest and the lowest ATMs(per 100,000 adults) of Tunisia?
Your answer should be compact. 7.79. What is the difference between the highest and the lowest ATMs(per 100,000 adults) in West Bank and Gaza?
Your answer should be compact. 7.7. 